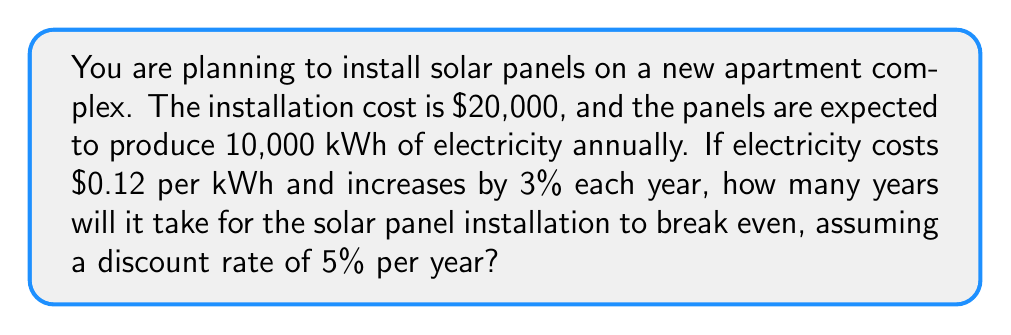Can you solve this math problem? To solve this problem, we need to calculate the present value of future electricity savings and compare it to the initial installation cost. We'll use the following steps:

1) Calculate the annual savings:
   Initial annual savings = 10,000 kWh × $0.12/kWh = $1,200

2) Account for the annual increase in electricity cost:
   Year 1: $1,200
   Year 2: $1,200 × 1.03 = $1,236
   Year 3: $1,236 × 1.03 = $1,273.08
   And so on...

3) Calculate the present value of these savings for each year, using the discount rate of 5%:
   PV = FV / (1 + r)^n, where r is the discount rate and n is the number of years

4) Sum the present values until they equal or exceed the installation cost of $20,000

Let's calculate this step by step:

Year 1: PV = $1,200 / (1.05)^1 = $1,142.86
Year 2: PV = $1,236 / (1.05)^2 = $1,121.63
Year 3: PV = $1,273.08 / (1.05)^3 = $1,100.88
...

We continue this process until the sum of the present values equals or exceeds $20,000.

The general formula for the present value in year n is:

$$ PV_n = \frac{1200 \times (1.03)^{n-1}}{(1.05)^n} $$

Using this formula and summing the results, we find that after 14 years, the cumulative present value is $19,947.62, and after 15 years, it's $20,992.54.

Therefore, the break-even point occurs during the 15th year.
Answer: It will take 15 years for the solar panel installation to break even. 